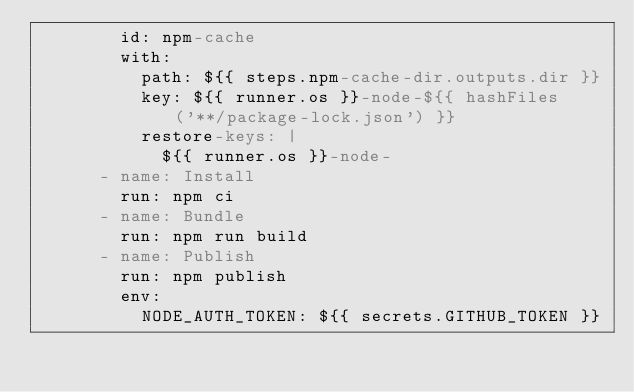Convert code to text. <code><loc_0><loc_0><loc_500><loc_500><_YAML_>        id: npm-cache
        with:
          path: ${{ steps.npm-cache-dir.outputs.dir }}
          key: ${{ runner.os }}-node-${{ hashFiles('**/package-lock.json') }}
          restore-keys: |
            ${{ runner.os }}-node-
      - name: Install
        run: npm ci
      - name: Bundle
        run: npm run build
      - name: Publish
        run: npm publish
        env:
          NODE_AUTH_TOKEN: ${{ secrets.GITHUB_TOKEN }}</code> 